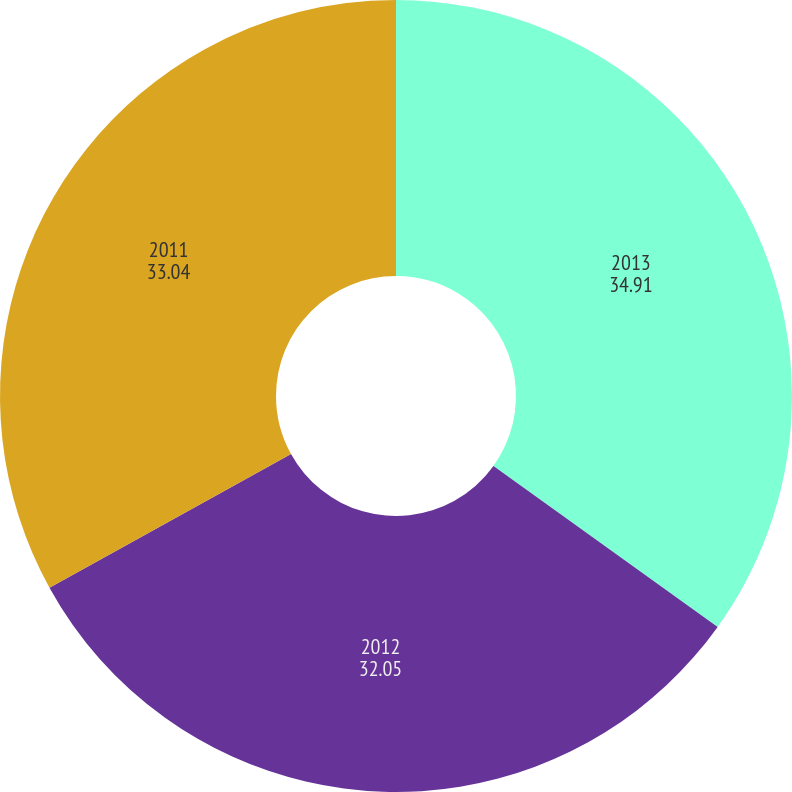Convert chart. <chart><loc_0><loc_0><loc_500><loc_500><pie_chart><fcel>2013<fcel>2012<fcel>2011<nl><fcel>34.91%<fcel>32.05%<fcel>33.04%<nl></chart> 